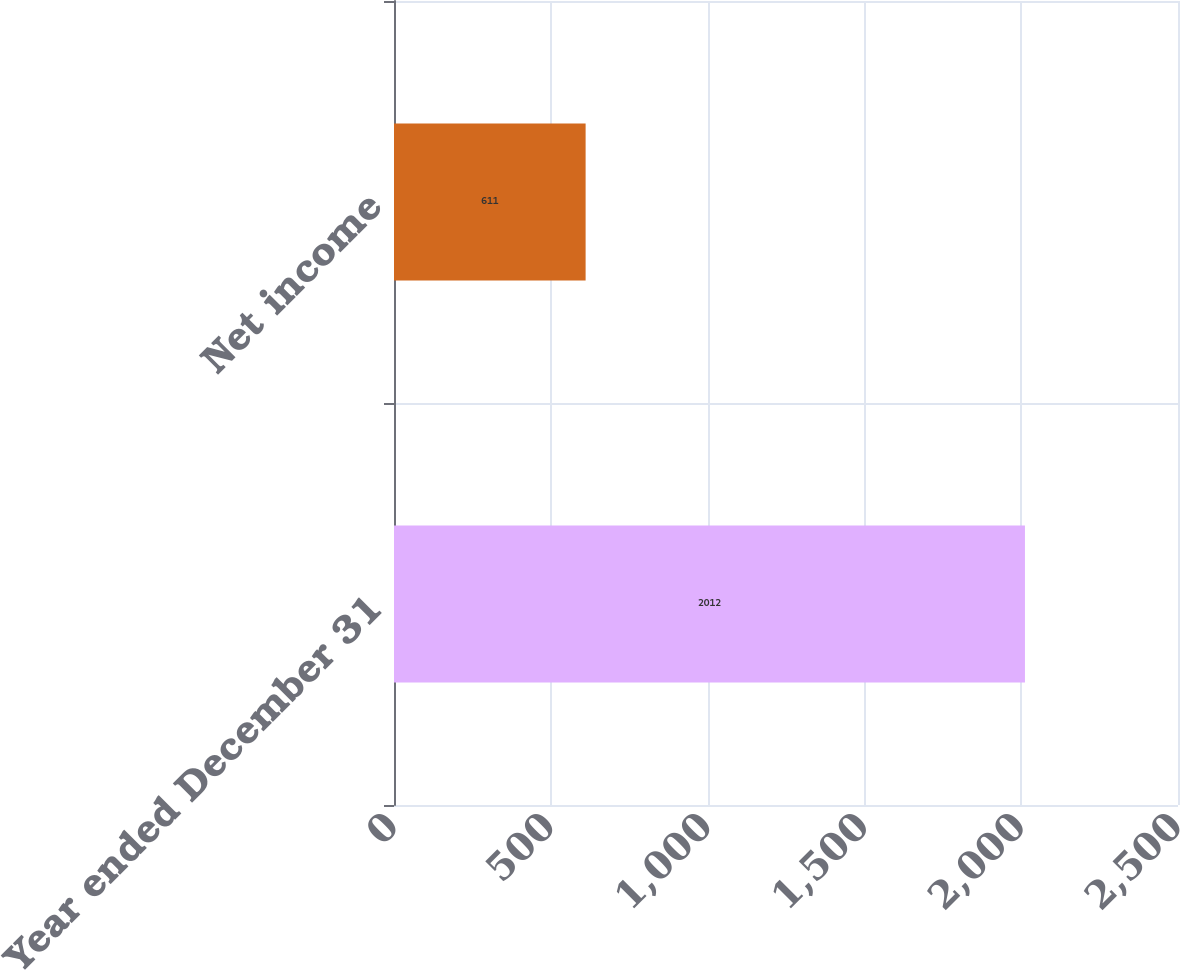<chart> <loc_0><loc_0><loc_500><loc_500><bar_chart><fcel>Year ended December 31<fcel>Net income<nl><fcel>2012<fcel>611<nl></chart> 